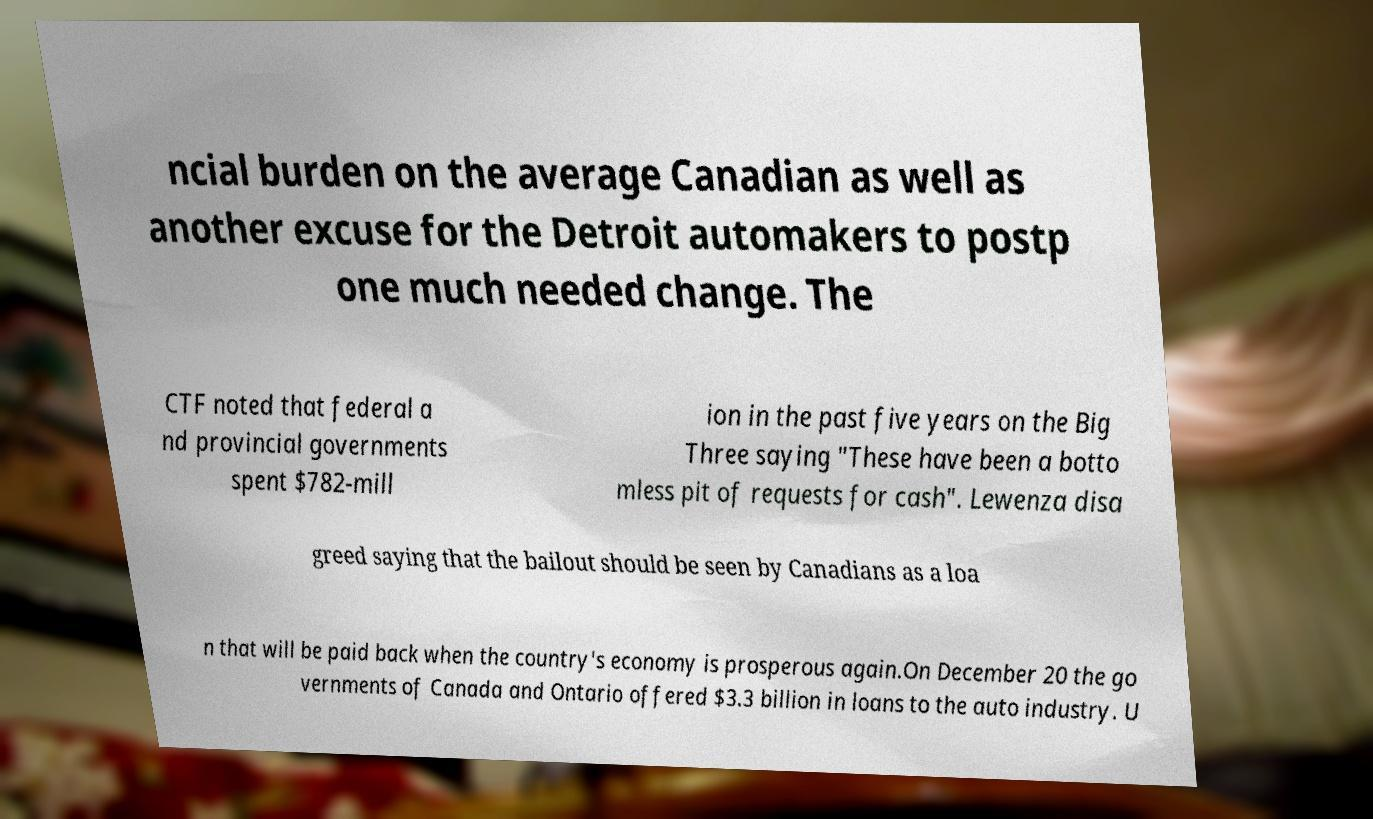I need the written content from this picture converted into text. Can you do that? ncial burden on the average Canadian as well as another excuse for the Detroit automakers to postp one much needed change. The CTF noted that federal a nd provincial governments spent $782-mill ion in the past five years on the Big Three saying "These have been a botto mless pit of requests for cash". Lewenza disa greed saying that the bailout should be seen by Canadians as a loa n that will be paid back when the country's economy is prosperous again.On December 20 the go vernments of Canada and Ontario offered $3.3 billion in loans to the auto industry. U 